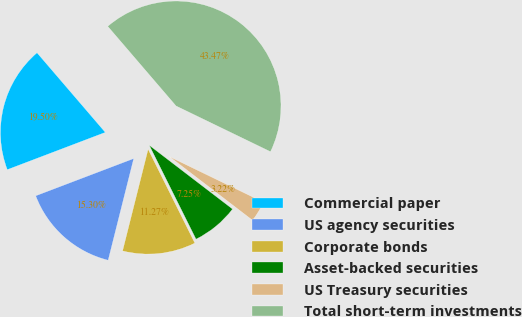Convert chart to OTSL. <chart><loc_0><loc_0><loc_500><loc_500><pie_chart><fcel>Commercial paper<fcel>US agency securities<fcel>Corporate bonds<fcel>Asset-backed securities<fcel>US Treasury securities<fcel>Total short-term investments<nl><fcel>19.5%<fcel>15.3%<fcel>11.27%<fcel>7.25%<fcel>3.22%<fcel>43.47%<nl></chart> 